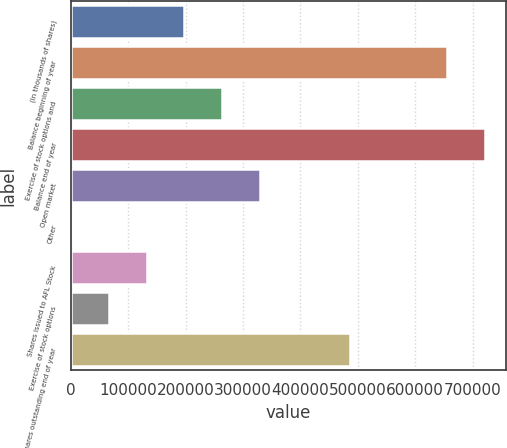<chart> <loc_0><loc_0><loc_500><loc_500><bar_chart><fcel>(In thousands of shares)<fcel>Balance beginning of year<fcel>Exercise of stock options and<fcel>Balance end of year<fcel>Open market<fcel>Other<fcel>Shares issued to AFL Stock<fcel>Exercise of stock options<fcel>Shares outstanding end of year<nl><fcel>197972<fcel>655715<fcel>263777<fcel>721520<fcel>329582<fcel>559<fcel>132168<fcel>66363.5<fcel>486530<nl></chart> 